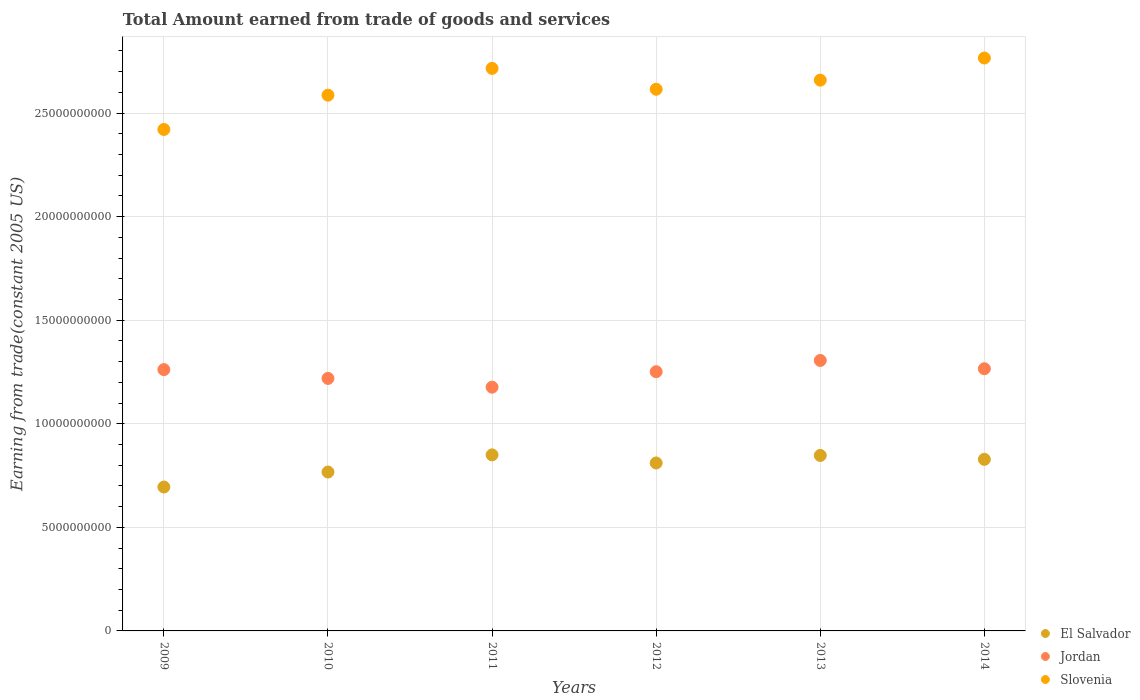How many different coloured dotlines are there?
Offer a very short reply. 3. What is the total amount earned by trading goods and services in El Salvador in 2009?
Provide a short and direct response. 6.95e+09. Across all years, what is the maximum total amount earned by trading goods and services in Slovenia?
Your answer should be compact. 2.77e+1. Across all years, what is the minimum total amount earned by trading goods and services in Slovenia?
Ensure brevity in your answer.  2.42e+1. In which year was the total amount earned by trading goods and services in Slovenia maximum?
Offer a terse response. 2014. What is the total total amount earned by trading goods and services in El Salvador in the graph?
Your answer should be very brief. 4.80e+1. What is the difference between the total amount earned by trading goods and services in Jordan in 2009 and that in 2014?
Your answer should be compact. -4.22e+07. What is the difference between the total amount earned by trading goods and services in El Salvador in 2013 and the total amount earned by trading goods and services in Jordan in 2009?
Your answer should be very brief. -4.14e+09. What is the average total amount earned by trading goods and services in El Salvador per year?
Keep it short and to the point. 8.00e+09. In the year 2010, what is the difference between the total amount earned by trading goods and services in Slovenia and total amount earned by trading goods and services in Jordan?
Give a very brief answer. 1.37e+1. What is the ratio of the total amount earned by trading goods and services in Jordan in 2010 to that in 2014?
Your response must be concise. 0.96. Is the total amount earned by trading goods and services in El Salvador in 2013 less than that in 2014?
Your answer should be very brief. No. Is the difference between the total amount earned by trading goods and services in Slovenia in 2012 and 2014 greater than the difference between the total amount earned by trading goods and services in Jordan in 2012 and 2014?
Offer a terse response. No. What is the difference between the highest and the second highest total amount earned by trading goods and services in Slovenia?
Keep it short and to the point. 5.01e+08. What is the difference between the highest and the lowest total amount earned by trading goods and services in Slovenia?
Provide a short and direct response. 3.45e+09. In how many years, is the total amount earned by trading goods and services in Slovenia greater than the average total amount earned by trading goods and services in Slovenia taken over all years?
Ensure brevity in your answer.  3. Is it the case that in every year, the sum of the total amount earned by trading goods and services in Jordan and total amount earned by trading goods and services in El Salvador  is greater than the total amount earned by trading goods and services in Slovenia?
Ensure brevity in your answer.  No. Is the total amount earned by trading goods and services in El Salvador strictly greater than the total amount earned by trading goods and services in Slovenia over the years?
Keep it short and to the point. No. Is the total amount earned by trading goods and services in El Salvador strictly less than the total amount earned by trading goods and services in Jordan over the years?
Your answer should be very brief. Yes. How many years are there in the graph?
Offer a terse response. 6. Does the graph contain grids?
Your response must be concise. Yes. Where does the legend appear in the graph?
Your response must be concise. Bottom right. How many legend labels are there?
Provide a succinct answer. 3. What is the title of the graph?
Ensure brevity in your answer.  Total Amount earned from trade of goods and services. What is the label or title of the X-axis?
Keep it short and to the point. Years. What is the label or title of the Y-axis?
Your response must be concise. Earning from trade(constant 2005 US). What is the Earning from trade(constant 2005 US) in El Salvador in 2009?
Ensure brevity in your answer.  6.95e+09. What is the Earning from trade(constant 2005 US) of Jordan in 2009?
Provide a succinct answer. 1.26e+1. What is the Earning from trade(constant 2005 US) of Slovenia in 2009?
Give a very brief answer. 2.42e+1. What is the Earning from trade(constant 2005 US) in El Salvador in 2010?
Ensure brevity in your answer.  7.67e+09. What is the Earning from trade(constant 2005 US) in Jordan in 2010?
Offer a terse response. 1.22e+1. What is the Earning from trade(constant 2005 US) of Slovenia in 2010?
Your answer should be compact. 2.59e+1. What is the Earning from trade(constant 2005 US) of El Salvador in 2011?
Provide a short and direct response. 8.50e+09. What is the Earning from trade(constant 2005 US) in Jordan in 2011?
Provide a short and direct response. 1.18e+1. What is the Earning from trade(constant 2005 US) of Slovenia in 2011?
Ensure brevity in your answer.  2.72e+1. What is the Earning from trade(constant 2005 US) in El Salvador in 2012?
Make the answer very short. 8.11e+09. What is the Earning from trade(constant 2005 US) in Jordan in 2012?
Your response must be concise. 1.25e+1. What is the Earning from trade(constant 2005 US) in Slovenia in 2012?
Give a very brief answer. 2.61e+1. What is the Earning from trade(constant 2005 US) in El Salvador in 2013?
Your answer should be compact. 8.47e+09. What is the Earning from trade(constant 2005 US) in Jordan in 2013?
Your answer should be very brief. 1.31e+1. What is the Earning from trade(constant 2005 US) of Slovenia in 2013?
Offer a very short reply. 2.66e+1. What is the Earning from trade(constant 2005 US) in El Salvador in 2014?
Make the answer very short. 8.28e+09. What is the Earning from trade(constant 2005 US) of Jordan in 2014?
Your answer should be compact. 1.27e+1. What is the Earning from trade(constant 2005 US) in Slovenia in 2014?
Your response must be concise. 2.77e+1. Across all years, what is the maximum Earning from trade(constant 2005 US) of El Salvador?
Give a very brief answer. 8.50e+09. Across all years, what is the maximum Earning from trade(constant 2005 US) of Jordan?
Provide a short and direct response. 1.31e+1. Across all years, what is the maximum Earning from trade(constant 2005 US) in Slovenia?
Your answer should be very brief. 2.77e+1. Across all years, what is the minimum Earning from trade(constant 2005 US) in El Salvador?
Offer a very short reply. 6.95e+09. Across all years, what is the minimum Earning from trade(constant 2005 US) of Jordan?
Provide a succinct answer. 1.18e+1. Across all years, what is the minimum Earning from trade(constant 2005 US) of Slovenia?
Your answer should be very brief. 2.42e+1. What is the total Earning from trade(constant 2005 US) of El Salvador in the graph?
Your answer should be very brief. 4.80e+1. What is the total Earning from trade(constant 2005 US) of Jordan in the graph?
Give a very brief answer. 7.48e+1. What is the total Earning from trade(constant 2005 US) of Slovenia in the graph?
Provide a short and direct response. 1.58e+11. What is the difference between the Earning from trade(constant 2005 US) of El Salvador in 2009 and that in 2010?
Provide a short and direct response. -7.24e+08. What is the difference between the Earning from trade(constant 2005 US) in Jordan in 2009 and that in 2010?
Make the answer very short. 4.25e+08. What is the difference between the Earning from trade(constant 2005 US) in Slovenia in 2009 and that in 2010?
Your response must be concise. -1.66e+09. What is the difference between the Earning from trade(constant 2005 US) in El Salvador in 2009 and that in 2011?
Your response must be concise. -1.55e+09. What is the difference between the Earning from trade(constant 2005 US) of Jordan in 2009 and that in 2011?
Keep it short and to the point. 8.47e+08. What is the difference between the Earning from trade(constant 2005 US) of Slovenia in 2009 and that in 2011?
Provide a succinct answer. -2.95e+09. What is the difference between the Earning from trade(constant 2005 US) of El Salvador in 2009 and that in 2012?
Give a very brief answer. -1.16e+09. What is the difference between the Earning from trade(constant 2005 US) of Jordan in 2009 and that in 2012?
Your response must be concise. 1.02e+08. What is the difference between the Earning from trade(constant 2005 US) of Slovenia in 2009 and that in 2012?
Give a very brief answer. -1.94e+09. What is the difference between the Earning from trade(constant 2005 US) in El Salvador in 2009 and that in 2013?
Provide a short and direct response. -1.52e+09. What is the difference between the Earning from trade(constant 2005 US) of Jordan in 2009 and that in 2013?
Give a very brief answer. -4.41e+08. What is the difference between the Earning from trade(constant 2005 US) of Slovenia in 2009 and that in 2013?
Ensure brevity in your answer.  -2.38e+09. What is the difference between the Earning from trade(constant 2005 US) in El Salvador in 2009 and that in 2014?
Ensure brevity in your answer.  -1.34e+09. What is the difference between the Earning from trade(constant 2005 US) of Jordan in 2009 and that in 2014?
Give a very brief answer. -4.22e+07. What is the difference between the Earning from trade(constant 2005 US) in Slovenia in 2009 and that in 2014?
Provide a succinct answer. -3.45e+09. What is the difference between the Earning from trade(constant 2005 US) of El Salvador in 2010 and that in 2011?
Keep it short and to the point. -8.28e+08. What is the difference between the Earning from trade(constant 2005 US) of Jordan in 2010 and that in 2011?
Provide a succinct answer. 4.22e+08. What is the difference between the Earning from trade(constant 2005 US) of Slovenia in 2010 and that in 2011?
Ensure brevity in your answer.  -1.29e+09. What is the difference between the Earning from trade(constant 2005 US) of El Salvador in 2010 and that in 2012?
Give a very brief answer. -4.37e+08. What is the difference between the Earning from trade(constant 2005 US) in Jordan in 2010 and that in 2012?
Provide a succinct answer. -3.24e+08. What is the difference between the Earning from trade(constant 2005 US) in Slovenia in 2010 and that in 2012?
Offer a very short reply. -2.86e+08. What is the difference between the Earning from trade(constant 2005 US) of El Salvador in 2010 and that in 2013?
Ensure brevity in your answer.  -8.00e+08. What is the difference between the Earning from trade(constant 2005 US) of Jordan in 2010 and that in 2013?
Your answer should be very brief. -8.67e+08. What is the difference between the Earning from trade(constant 2005 US) in Slovenia in 2010 and that in 2013?
Give a very brief answer. -7.26e+08. What is the difference between the Earning from trade(constant 2005 US) of El Salvador in 2010 and that in 2014?
Offer a terse response. -6.12e+08. What is the difference between the Earning from trade(constant 2005 US) of Jordan in 2010 and that in 2014?
Provide a succinct answer. -4.68e+08. What is the difference between the Earning from trade(constant 2005 US) of Slovenia in 2010 and that in 2014?
Give a very brief answer. -1.79e+09. What is the difference between the Earning from trade(constant 2005 US) in El Salvador in 2011 and that in 2012?
Your response must be concise. 3.91e+08. What is the difference between the Earning from trade(constant 2005 US) in Jordan in 2011 and that in 2012?
Your answer should be very brief. -7.46e+08. What is the difference between the Earning from trade(constant 2005 US) of Slovenia in 2011 and that in 2012?
Give a very brief answer. 1.01e+09. What is the difference between the Earning from trade(constant 2005 US) in El Salvador in 2011 and that in 2013?
Your response must be concise. 2.75e+07. What is the difference between the Earning from trade(constant 2005 US) of Jordan in 2011 and that in 2013?
Your answer should be very brief. -1.29e+09. What is the difference between the Earning from trade(constant 2005 US) of Slovenia in 2011 and that in 2013?
Your answer should be very brief. 5.66e+08. What is the difference between the Earning from trade(constant 2005 US) in El Salvador in 2011 and that in 2014?
Offer a very short reply. 2.15e+08. What is the difference between the Earning from trade(constant 2005 US) of Jordan in 2011 and that in 2014?
Offer a terse response. -8.90e+08. What is the difference between the Earning from trade(constant 2005 US) in Slovenia in 2011 and that in 2014?
Give a very brief answer. -5.01e+08. What is the difference between the Earning from trade(constant 2005 US) in El Salvador in 2012 and that in 2013?
Offer a terse response. -3.64e+08. What is the difference between the Earning from trade(constant 2005 US) of Jordan in 2012 and that in 2013?
Your answer should be very brief. -5.43e+08. What is the difference between the Earning from trade(constant 2005 US) of Slovenia in 2012 and that in 2013?
Your answer should be compact. -4.40e+08. What is the difference between the Earning from trade(constant 2005 US) of El Salvador in 2012 and that in 2014?
Your answer should be compact. -1.76e+08. What is the difference between the Earning from trade(constant 2005 US) of Jordan in 2012 and that in 2014?
Provide a short and direct response. -1.44e+08. What is the difference between the Earning from trade(constant 2005 US) of Slovenia in 2012 and that in 2014?
Your answer should be very brief. -1.51e+09. What is the difference between the Earning from trade(constant 2005 US) of El Salvador in 2013 and that in 2014?
Offer a very short reply. 1.88e+08. What is the difference between the Earning from trade(constant 2005 US) of Jordan in 2013 and that in 2014?
Your answer should be very brief. 3.99e+08. What is the difference between the Earning from trade(constant 2005 US) of Slovenia in 2013 and that in 2014?
Provide a short and direct response. -1.07e+09. What is the difference between the Earning from trade(constant 2005 US) of El Salvador in 2009 and the Earning from trade(constant 2005 US) of Jordan in 2010?
Ensure brevity in your answer.  -5.24e+09. What is the difference between the Earning from trade(constant 2005 US) of El Salvador in 2009 and the Earning from trade(constant 2005 US) of Slovenia in 2010?
Your answer should be compact. -1.89e+1. What is the difference between the Earning from trade(constant 2005 US) in Jordan in 2009 and the Earning from trade(constant 2005 US) in Slovenia in 2010?
Keep it short and to the point. -1.32e+1. What is the difference between the Earning from trade(constant 2005 US) in El Salvador in 2009 and the Earning from trade(constant 2005 US) in Jordan in 2011?
Provide a succinct answer. -4.82e+09. What is the difference between the Earning from trade(constant 2005 US) of El Salvador in 2009 and the Earning from trade(constant 2005 US) of Slovenia in 2011?
Your answer should be compact. -2.02e+1. What is the difference between the Earning from trade(constant 2005 US) of Jordan in 2009 and the Earning from trade(constant 2005 US) of Slovenia in 2011?
Provide a succinct answer. -1.45e+1. What is the difference between the Earning from trade(constant 2005 US) of El Salvador in 2009 and the Earning from trade(constant 2005 US) of Jordan in 2012?
Ensure brevity in your answer.  -5.57e+09. What is the difference between the Earning from trade(constant 2005 US) in El Salvador in 2009 and the Earning from trade(constant 2005 US) in Slovenia in 2012?
Give a very brief answer. -1.92e+1. What is the difference between the Earning from trade(constant 2005 US) of Jordan in 2009 and the Earning from trade(constant 2005 US) of Slovenia in 2012?
Make the answer very short. -1.35e+1. What is the difference between the Earning from trade(constant 2005 US) in El Salvador in 2009 and the Earning from trade(constant 2005 US) in Jordan in 2013?
Provide a short and direct response. -6.11e+09. What is the difference between the Earning from trade(constant 2005 US) in El Salvador in 2009 and the Earning from trade(constant 2005 US) in Slovenia in 2013?
Offer a terse response. -1.96e+1. What is the difference between the Earning from trade(constant 2005 US) of Jordan in 2009 and the Earning from trade(constant 2005 US) of Slovenia in 2013?
Make the answer very short. -1.40e+1. What is the difference between the Earning from trade(constant 2005 US) of El Salvador in 2009 and the Earning from trade(constant 2005 US) of Jordan in 2014?
Your answer should be compact. -5.71e+09. What is the difference between the Earning from trade(constant 2005 US) of El Salvador in 2009 and the Earning from trade(constant 2005 US) of Slovenia in 2014?
Provide a succinct answer. -2.07e+1. What is the difference between the Earning from trade(constant 2005 US) in Jordan in 2009 and the Earning from trade(constant 2005 US) in Slovenia in 2014?
Your answer should be very brief. -1.50e+1. What is the difference between the Earning from trade(constant 2005 US) in El Salvador in 2010 and the Earning from trade(constant 2005 US) in Jordan in 2011?
Your answer should be very brief. -4.10e+09. What is the difference between the Earning from trade(constant 2005 US) of El Salvador in 2010 and the Earning from trade(constant 2005 US) of Slovenia in 2011?
Your answer should be compact. -1.95e+1. What is the difference between the Earning from trade(constant 2005 US) in Jordan in 2010 and the Earning from trade(constant 2005 US) in Slovenia in 2011?
Your answer should be compact. -1.50e+1. What is the difference between the Earning from trade(constant 2005 US) in El Salvador in 2010 and the Earning from trade(constant 2005 US) in Jordan in 2012?
Provide a short and direct response. -4.84e+09. What is the difference between the Earning from trade(constant 2005 US) in El Salvador in 2010 and the Earning from trade(constant 2005 US) in Slovenia in 2012?
Your answer should be very brief. -1.85e+1. What is the difference between the Earning from trade(constant 2005 US) in Jordan in 2010 and the Earning from trade(constant 2005 US) in Slovenia in 2012?
Give a very brief answer. -1.40e+1. What is the difference between the Earning from trade(constant 2005 US) in El Salvador in 2010 and the Earning from trade(constant 2005 US) in Jordan in 2013?
Offer a very short reply. -5.39e+09. What is the difference between the Earning from trade(constant 2005 US) of El Salvador in 2010 and the Earning from trade(constant 2005 US) of Slovenia in 2013?
Your answer should be compact. -1.89e+1. What is the difference between the Earning from trade(constant 2005 US) in Jordan in 2010 and the Earning from trade(constant 2005 US) in Slovenia in 2013?
Your answer should be very brief. -1.44e+1. What is the difference between the Earning from trade(constant 2005 US) of El Salvador in 2010 and the Earning from trade(constant 2005 US) of Jordan in 2014?
Provide a short and direct response. -4.99e+09. What is the difference between the Earning from trade(constant 2005 US) of El Salvador in 2010 and the Earning from trade(constant 2005 US) of Slovenia in 2014?
Your answer should be very brief. -2.00e+1. What is the difference between the Earning from trade(constant 2005 US) of Jordan in 2010 and the Earning from trade(constant 2005 US) of Slovenia in 2014?
Your answer should be very brief. -1.55e+1. What is the difference between the Earning from trade(constant 2005 US) of El Salvador in 2011 and the Earning from trade(constant 2005 US) of Jordan in 2012?
Your answer should be compact. -4.02e+09. What is the difference between the Earning from trade(constant 2005 US) in El Salvador in 2011 and the Earning from trade(constant 2005 US) in Slovenia in 2012?
Your answer should be compact. -1.77e+1. What is the difference between the Earning from trade(constant 2005 US) of Jordan in 2011 and the Earning from trade(constant 2005 US) of Slovenia in 2012?
Offer a very short reply. -1.44e+1. What is the difference between the Earning from trade(constant 2005 US) in El Salvador in 2011 and the Earning from trade(constant 2005 US) in Jordan in 2013?
Make the answer very short. -4.56e+09. What is the difference between the Earning from trade(constant 2005 US) in El Salvador in 2011 and the Earning from trade(constant 2005 US) in Slovenia in 2013?
Make the answer very short. -1.81e+1. What is the difference between the Earning from trade(constant 2005 US) of Jordan in 2011 and the Earning from trade(constant 2005 US) of Slovenia in 2013?
Ensure brevity in your answer.  -1.48e+1. What is the difference between the Earning from trade(constant 2005 US) of El Salvador in 2011 and the Earning from trade(constant 2005 US) of Jordan in 2014?
Offer a terse response. -4.16e+09. What is the difference between the Earning from trade(constant 2005 US) of El Salvador in 2011 and the Earning from trade(constant 2005 US) of Slovenia in 2014?
Your answer should be very brief. -1.92e+1. What is the difference between the Earning from trade(constant 2005 US) in Jordan in 2011 and the Earning from trade(constant 2005 US) in Slovenia in 2014?
Keep it short and to the point. -1.59e+1. What is the difference between the Earning from trade(constant 2005 US) of El Salvador in 2012 and the Earning from trade(constant 2005 US) of Jordan in 2013?
Offer a very short reply. -4.95e+09. What is the difference between the Earning from trade(constant 2005 US) in El Salvador in 2012 and the Earning from trade(constant 2005 US) in Slovenia in 2013?
Keep it short and to the point. -1.85e+1. What is the difference between the Earning from trade(constant 2005 US) of Jordan in 2012 and the Earning from trade(constant 2005 US) of Slovenia in 2013?
Offer a terse response. -1.41e+1. What is the difference between the Earning from trade(constant 2005 US) in El Salvador in 2012 and the Earning from trade(constant 2005 US) in Jordan in 2014?
Your response must be concise. -4.55e+09. What is the difference between the Earning from trade(constant 2005 US) in El Salvador in 2012 and the Earning from trade(constant 2005 US) in Slovenia in 2014?
Offer a very short reply. -1.95e+1. What is the difference between the Earning from trade(constant 2005 US) of Jordan in 2012 and the Earning from trade(constant 2005 US) of Slovenia in 2014?
Provide a succinct answer. -1.51e+1. What is the difference between the Earning from trade(constant 2005 US) in El Salvador in 2013 and the Earning from trade(constant 2005 US) in Jordan in 2014?
Your answer should be very brief. -4.19e+09. What is the difference between the Earning from trade(constant 2005 US) in El Salvador in 2013 and the Earning from trade(constant 2005 US) in Slovenia in 2014?
Keep it short and to the point. -1.92e+1. What is the difference between the Earning from trade(constant 2005 US) of Jordan in 2013 and the Earning from trade(constant 2005 US) of Slovenia in 2014?
Provide a short and direct response. -1.46e+1. What is the average Earning from trade(constant 2005 US) in El Salvador per year?
Ensure brevity in your answer.  8.00e+09. What is the average Earning from trade(constant 2005 US) in Jordan per year?
Keep it short and to the point. 1.25e+1. What is the average Earning from trade(constant 2005 US) of Slovenia per year?
Provide a short and direct response. 2.63e+1. In the year 2009, what is the difference between the Earning from trade(constant 2005 US) in El Salvador and Earning from trade(constant 2005 US) in Jordan?
Ensure brevity in your answer.  -5.67e+09. In the year 2009, what is the difference between the Earning from trade(constant 2005 US) of El Salvador and Earning from trade(constant 2005 US) of Slovenia?
Your answer should be compact. -1.73e+1. In the year 2009, what is the difference between the Earning from trade(constant 2005 US) in Jordan and Earning from trade(constant 2005 US) in Slovenia?
Make the answer very short. -1.16e+1. In the year 2010, what is the difference between the Earning from trade(constant 2005 US) of El Salvador and Earning from trade(constant 2005 US) of Jordan?
Provide a short and direct response. -4.52e+09. In the year 2010, what is the difference between the Earning from trade(constant 2005 US) of El Salvador and Earning from trade(constant 2005 US) of Slovenia?
Give a very brief answer. -1.82e+1. In the year 2010, what is the difference between the Earning from trade(constant 2005 US) in Jordan and Earning from trade(constant 2005 US) in Slovenia?
Provide a succinct answer. -1.37e+1. In the year 2011, what is the difference between the Earning from trade(constant 2005 US) in El Salvador and Earning from trade(constant 2005 US) in Jordan?
Ensure brevity in your answer.  -3.27e+09. In the year 2011, what is the difference between the Earning from trade(constant 2005 US) of El Salvador and Earning from trade(constant 2005 US) of Slovenia?
Your answer should be very brief. -1.87e+1. In the year 2011, what is the difference between the Earning from trade(constant 2005 US) in Jordan and Earning from trade(constant 2005 US) in Slovenia?
Provide a succinct answer. -1.54e+1. In the year 2012, what is the difference between the Earning from trade(constant 2005 US) of El Salvador and Earning from trade(constant 2005 US) of Jordan?
Provide a short and direct response. -4.41e+09. In the year 2012, what is the difference between the Earning from trade(constant 2005 US) in El Salvador and Earning from trade(constant 2005 US) in Slovenia?
Provide a short and direct response. -1.80e+1. In the year 2012, what is the difference between the Earning from trade(constant 2005 US) of Jordan and Earning from trade(constant 2005 US) of Slovenia?
Your response must be concise. -1.36e+1. In the year 2013, what is the difference between the Earning from trade(constant 2005 US) of El Salvador and Earning from trade(constant 2005 US) of Jordan?
Provide a succinct answer. -4.59e+09. In the year 2013, what is the difference between the Earning from trade(constant 2005 US) in El Salvador and Earning from trade(constant 2005 US) in Slovenia?
Your answer should be compact. -1.81e+1. In the year 2013, what is the difference between the Earning from trade(constant 2005 US) in Jordan and Earning from trade(constant 2005 US) in Slovenia?
Keep it short and to the point. -1.35e+1. In the year 2014, what is the difference between the Earning from trade(constant 2005 US) of El Salvador and Earning from trade(constant 2005 US) of Jordan?
Your response must be concise. -4.37e+09. In the year 2014, what is the difference between the Earning from trade(constant 2005 US) of El Salvador and Earning from trade(constant 2005 US) of Slovenia?
Provide a succinct answer. -1.94e+1. In the year 2014, what is the difference between the Earning from trade(constant 2005 US) in Jordan and Earning from trade(constant 2005 US) in Slovenia?
Make the answer very short. -1.50e+1. What is the ratio of the Earning from trade(constant 2005 US) in El Salvador in 2009 to that in 2010?
Provide a short and direct response. 0.91. What is the ratio of the Earning from trade(constant 2005 US) in Jordan in 2009 to that in 2010?
Your response must be concise. 1.03. What is the ratio of the Earning from trade(constant 2005 US) of Slovenia in 2009 to that in 2010?
Offer a terse response. 0.94. What is the ratio of the Earning from trade(constant 2005 US) of El Salvador in 2009 to that in 2011?
Give a very brief answer. 0.82. What is the ratio of the Earning from trade(constant 2005 US) in Jordan in 2009 to that in 2011?
Your answer should be very brief. 1.07. What is the ratio of the Earning from trade(constant 2005 US) of Slovenia in 2009 to that in 2011?
Keep it short and to the point. 0.89. What is the ratio of the Earning from trade(constant 2005 US) in El Salvador in 2009 to that in 2012?
Give a very brief answer. 0.86. What is the ratio of the Earning from trade(constant 2005 US) in Jordan in 2009 to that in 2012?
Provide a succinct answer. 1.01. What is the ratio of the Earning from trade(constant 2005 US) in Slovenia in 2009 to that in 2012?
Offer a terse response. 0.93. What is the ratio of the Earning from trade(constant 2005 US) of El Salvador in 2009 to that in 2013?
Keep it short and to the point. 0.82. What is the ratio of the Earning from trade(constant 2005 US) of Jordan in 2009 to that in 2013?
Provide a succinct answer. 0.97. What is the ratio of the Earning from trade(constant 2005 US) in Slovenia in 2009 to that in 2013?
Provide a short and direct response. 0.91. What is the ratio of the Earning from trade(constant 2005 US) in El Salvador in 2009 to that in 2014?
Provide a short and direct response. 0.84. What is the ratio of the Earning from trade(constant 2005 US) of Jordan in 2009 to that in 2014?
Your answer should be compact. 1. What is the ratio of the Earning from trade(constant 2005 US) of Slovenia in 2009 to that in 2014?
Offer a very short reply. 0.88. What is the ratio of the Earning from trade(constant 2005 US) in El Salvador in 2010 to that in 2011?
Your answer should be compact. 0.9. What is the ratio of the Earning from trade(constant 2005 US) in Jordan in 2010 to that in 2011?
Your answer should be very brief. 1.04. What is the ratio of the Earning from trade(constant 2005 US) in El Salvador in 2010 to that in 2012?
Keep it short and to the point. 0.95. What is the ratio of the Earning from trade(constant 2005 US) of Jordan in 2010 to that in 2012?
Keep it short and to the point. 0.97. What is the ratio of the Earning from trade(constant 2005 US) in Slovenia in 2010 to that in 2012?
Your answer should be compact. 0.99. What is the ratio of the Earning from trade(constant 2005 US) in El Salvador in 2010 to that in 2013?
Keep it short and to the point. 0.91. What is the ratio of the Earning from trade(constant 2005 US) in Jordan in 2010 to that in 2013?
Keep it short and to the point. 0.93. What is the ratio of the Earning from trade(constant 2005 US) of Slovenia in 2010 to that in 2013?
Offer a very short reply. 0.97. What is the ratio of the Earning from trade(constant 2005 US) of El Salvador in 2010 to that in 2014?
Keep it short and to the point. 0.93. What is the ratio of the Earning from trade(constant 2005 US) in Jordan in 2010 to that in 2014?
Provide a succinct answer. 0.96. What is the ratio of the Earning from trade(constant 2005 US) in Slovenia in 2010 to that in 2014?
Offer a terse response. 0.94. What is the ratio of the Earning from trade(constant 2005 US) of El Salvador in 2011 to that in 2012?
Make the answer very short. 1.05. What is the ratio of the Earning from trade(constant 2005 US) of Jordan in 2011 to that in 2012?
Your answer should be very brief. 0.94. What is the ratio of the Earning from trade(constant 2005 US) in Slovenia in 2011 to that in 2012?
Give a very brief answer. 1.04. What is the ratio of the Earning from trade(constant 2005 US) in El Salvador in 2011 to that in 2013?
Ensure brevity in your answer.  1. What is the ratio of the Earning from trade(constant 2005 US) in Jordan in 2011 to that in 2013?
Provide a short and direct response. 0.9. What is the ratio of the Earning from trade(constant 2005 US) in Slovenia in 2011 to that in 2013?
Offer a very short reply. 1.02. What is the ratio of the Earning from trade(constant 2005 US) in El Salvador in 2011 to that in 2014?
Offer a terse response. 1.03. What is the ratio of the Earning from trade(constant 2005 US) in Jordan in 2011 to that in 2014?
Ensure brevity in your answer.  0.93. What is the ratio of the Earning from trade(constant 2005 US) in Slovenia in 2011 to that in 2014?
Your answer should be compact. 0.98. What is the ratio of the Earning from trade(constant 2005 US) in El Salvador in 2012 to that in 2013?
Offer a very short reply. 0.96. What is the ratio of the Earning from trade(constant 2005 US) in Jordan in 2012 to that in 2013?
Your answer should be compact. 0.96. What is the ratio of the Earning from trade(constant 2005 US) of Slovenia in 2012 to that in 2013?
Your response must be concise. 0.98. What is the ratio of the Earning from trade(constant 2005 US) of El Salvador in 2012 to that in 2014?
Ensure brevity in your answer.  0.98. What is the ratio of the Earning from trade(constant 2005 US) in Slovenia in 2012 to that in 2014?
Give a very brief answer. 0.95. What is the ratio of the Earning from trade(constant 2005 US) in El Salvador in 2013 to that in 2014?
Make the answer very short. 1.02. What is the ratio of the Earning from trade(constant 2005 US) of Jordan in 2013 to that in 2014?
Your answer should be compact. 1.03. What is the ratio of the Earning from trade(constant 2005 US) in Slovenia in 2013 to that in 2014?
Give a very brief answer. 0.96. What is the difference between the highest and the second highest Earning from trade(constant 2005 US) in El Salvador?
Offer a terse response. 2.75e+07. What is the difference between the highest and the second highest Earning from trade(constant 2005 US) of Jordan?
Your response must be concise. 3.99e+08. What is the difference between the highest and the second highest Earning from trade(constant 2005 US) of Slovenia?
Your answer should be very brief. 5.01e+08. What is the difference between the highest and the lowest Earning from trade(constant 2005 US) in El Salvador?
Ensure brevity in your answer.  1.55e+09. What is the difference between the highest and the lowest Earning from trade(constant 2005 US) in Jordan?
Your response must be concise. 1.29e+09. What is the difference between the highest and the lowest Earning from trade(constant 2005 US) in Slovenia?
Ensure brevity in your answer.  3.45e+09. 